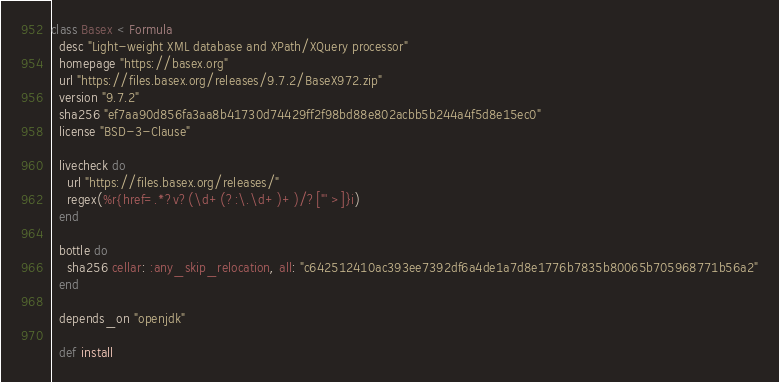Convert code to text. <code><loc_0><loc_0><loc_500><loc_500><_Ruby_>class Basex < Formula
  desc "Light-weight XML database and XPath/XQuery processor"
  homepage "https://basex.org"
  url "https://files.basex.org/releases/9.7.2/BaseX972.zip"
  version "9.7.2"
  sha256 "ef7aa90d856fa3aa8b41730d74429ff2f98bd88e802acbb5b244a4f5d8e15ec0"
  license "BSD-3-Clause"

  livecheck do
    url "https://files.basex.org/releases/"
    regex(%r{href=.*?v?(\d+(?:\.\d+)+)/?["' >]}i)
  end

  bottle do
    sha256 cellar: :any_skip_relocation, all: "c642512410ac393ee7392df6a4de1a7d8e1776b7835b80065b705968771b56a2"
  end

  depends_on "openjdk"

  def install</code> 